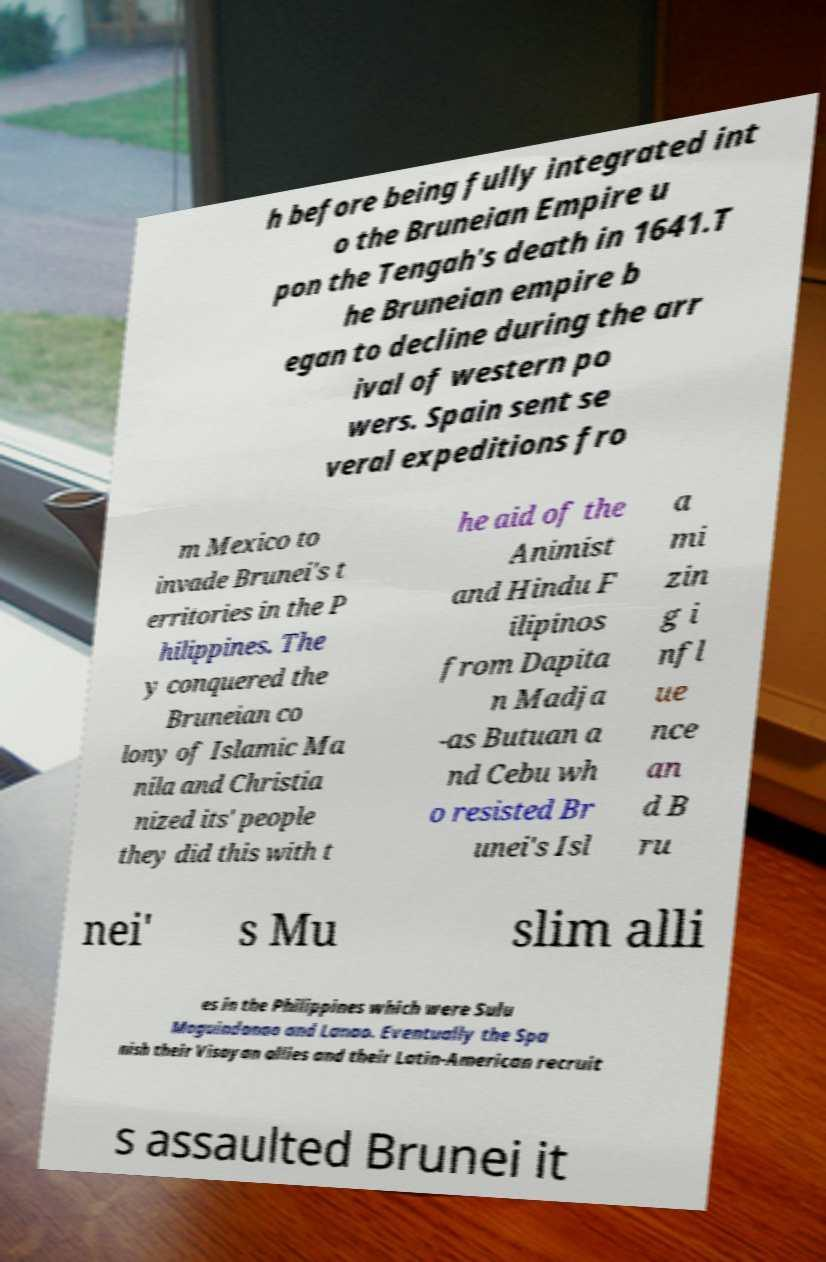I need the written content from this picture converted into text. Can you do that? h before being fully integrated int o the Bruneian Empire u pon the Tengah's death in 1641.T he Bruneian empire b egan to decline during the arr ival of western po wers. Spain sent se veral expeditions fro m Mexico to invade Brunei's t erritories in the P hilippines. The y conquered the Bruneian co lony of Islamic Ma nila and Christia nized its' people they did this with t he aid of the Animist and Hindu F ilipinos from Dapita n Madja -as Butuan a nd Cebu wh o resisted Br unei's Isl a mi zin g i nfl ue nce an d B ru nei' s Mu slim alli es in the Philippines which were Sulu Maguindanao and Lanao. Eventually the Spa nish their Visayan allies and their Latin-American recruit s assaulted Brunei it 